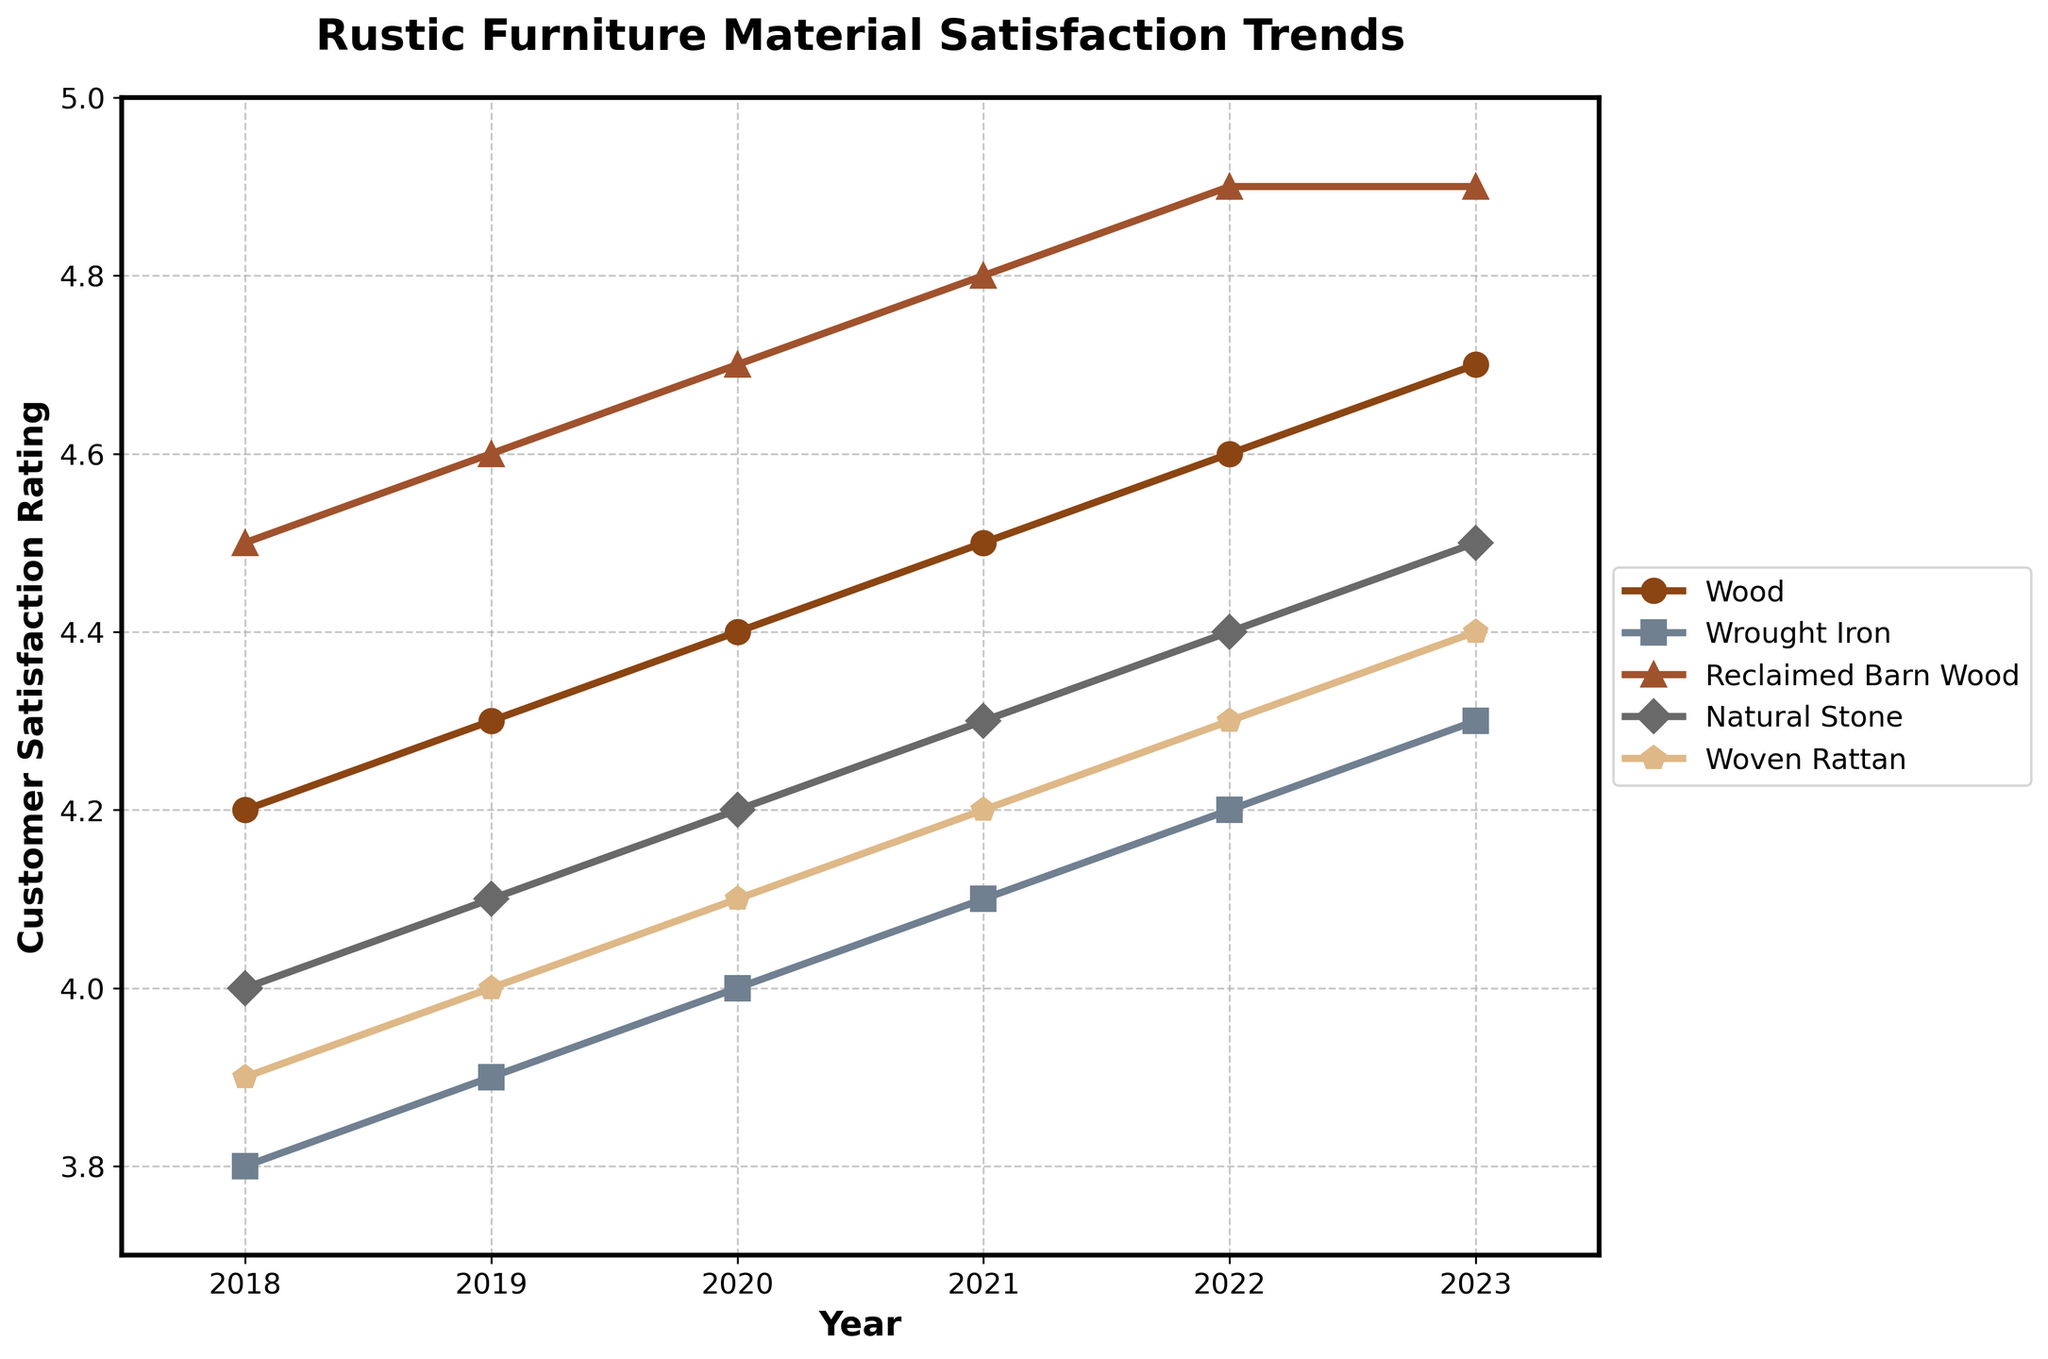What's the average customer satisfaction rating for Reclaimed Barn Wood over the years? To find the average, sum the satisfaction ratings for Reclaimed Barn Wood from 2018 to 2023: 4.5 + 4.6 + 4.7 + 4.8 + 4.9 + 4.9. Then divide by the number of years (6). So, the total is 28.4, and the average is 28.4 / 6.
Answer: 4.73 Which material had the highest customer satisfaction rating in 2021? Look at the customer satisfaction ratings for all materials in 2021: Wood (4.5), Wrought Iron (4.1), Reclaimed Barn Wood (4.8), Natural Stone (4.3), Woven Rattan (4.2). The highest rating is 4.8 for Reclaimed Barn Wood.
Answer: Reclaimed Barn Wood Has the customer satisfaction rating for Wrought Iron ever exceeded that of Natural Stone from 2018 to 2023? Compare the customer satisfaction ratings for Wrought Iron and Natural Stone each year from 2018 to 2023. Wrought Iron ratings: 3.8, 3.9, 4.0, 4.1, 4.2, 4.3. Natural Stone ratings: 4.0, 4.1, 4.2, 4.3, 4.4, 4.5. Wrought Iron never exceeds Natural Stone in any year.
Answer: No What's the difference in customer satisfaction ratings between the highest-rated and lowest-rated materials in 2018? Find the highest and lowest ratings in 2018: Reclaimed Barn Wood (4.5) is the highest, and Wrought Iron (3.8) is the lowest. The difference is 4.5 - 3.8.
Answer: 0.7 Which material showed the most consistent increase in customer satisfaction ratings over the years? To determine consistency, observe the annual increases in each material’s ratings. Reclaimed Barn Wood consistently increases by 0.1 each year (4.5, 4.6, 4.7, 4.8, 4.9, 4.9), while other materials show varying increments.
Answer: Reclaimed Barn Wood In what year did Wood achieve a customer satisfaction rating of 4.6? Check the ratings of Wood over the years: 2018 (4.2), 2019 (4.3), 2020 (4.4), 2021 (4.5), 2022 (4.6), 2023 (4.7). Wood achieved a rating of 4.6 in 2022.
Answer: 2022 Which material had the greatest increase in customer satisfaction rating from 2018 to 2023? Calculate the increase for each material over the period: 
Wood: 4.7 - 4.2 = 0.5 
Wrought Iron: 4.3 - 3.8 = 0.5 
Reclaimed Barn Wood: 4.9 - 4.5 = 0.4 
Natural Stone: 4.5 - 4.0 = 0.5 
Woven Rattan: 4.4 - 3.9 = 0.5 
All have the same increase of 0.5.
Answer: Wood, Wrought Iron, Natural Stone, Woven Rattan What is the overall trend in customer satisfaction ratings for Woven Rattan from 2018 to 2023? Review the ratings for Woven Rattan: 2018 (3.9), 2019 (4.0), 2020 (4.1), 2021 (4.2), 2022 (4.3), 2023 (4.4). The ratings steadily increase each year, indicating an upward trend.
Answer: Upward trend 